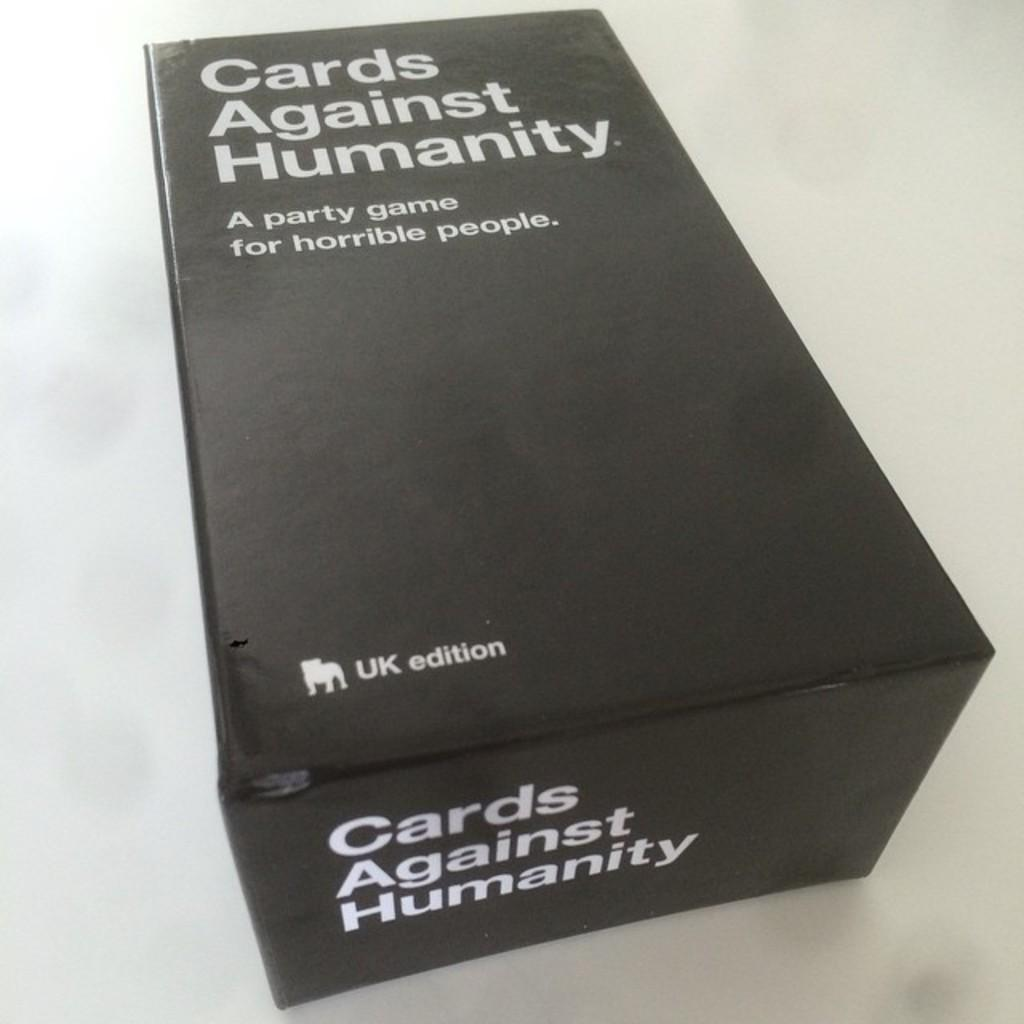<image>
Give a short and clear explanation of the subsequent image. A black box advertising a game called Cards against Humanity 